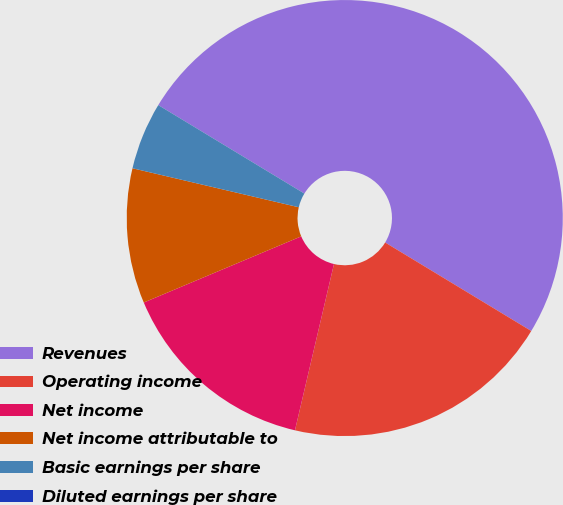Convert chart. <chart><loc_0><loc_0><loc_500><loc_500><pie_chart><fcel>Revenues<fcel>Operating income<fcel>Net income<fcel>Net income attributable to<fcel>Basic earnings per share<fcel>Diluted earnings per share<nl><fcel>50.0%<fcel>20.0%<fcel>15.0%<fcel>10.0%<fcel>5.0%<fcel>0.0%<nl></chart> 